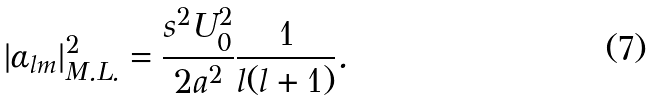Convert formula to latex. <formula><loc_0><loc_0><loc_500><loc_500>| \alpha _ { l m } | ^ { 2 } _ { M . L . } = \frac { s ^ { 2 } U _ { 0 } ^ { 2 } } { 2 a ^ { 2 } } \frac { 1 } { l ( l + 1 ) } .</formula> 